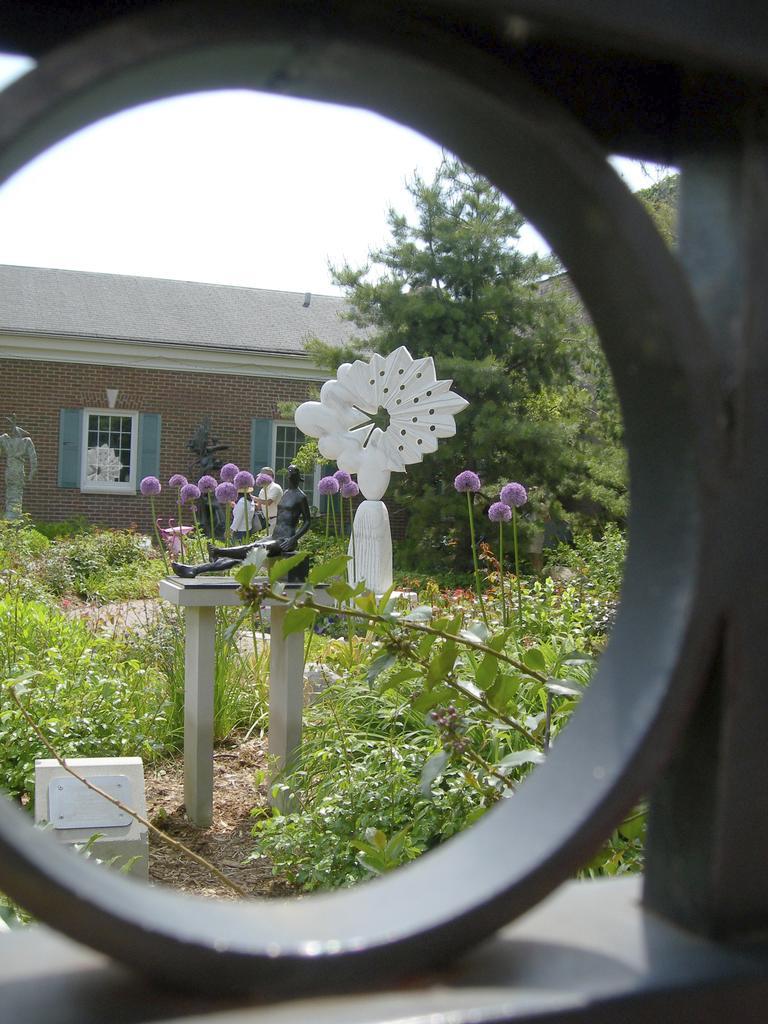Could you give a brief overview of what you see in this image? In this image we can see house, windows, flowers, plants, trees and sky. 